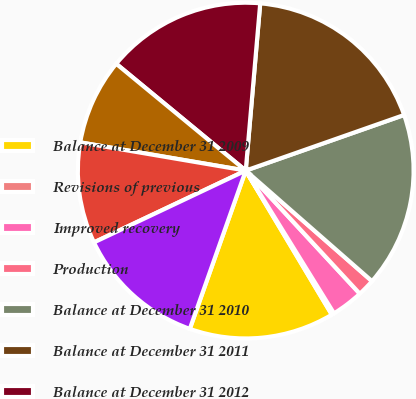Convert chart to OTSL. <chart><loc_0><loc_0><loc_500><loc_500><pie_chart><fcel>Balance at December 31 2009<fcel>Revisions of previous<fcel>Improved recovery<fcel>Production<fcel>Balance at December 31 2010<fcel>Balance at December 31 2011<fcel>Balance at December 31 2012<fcel>December 31 2009<fcel>December 31 2010<fcel>December 31 2011<nl><fcel>13.98%<fcel>0.24%<fcel>3.08%<fcel>1.66%<fcel>16.82%<fcel>18.25%<fcel>15.4%<fcel>8.29%<fcel>9.72%<fcel>12.56%<nl></chart> 